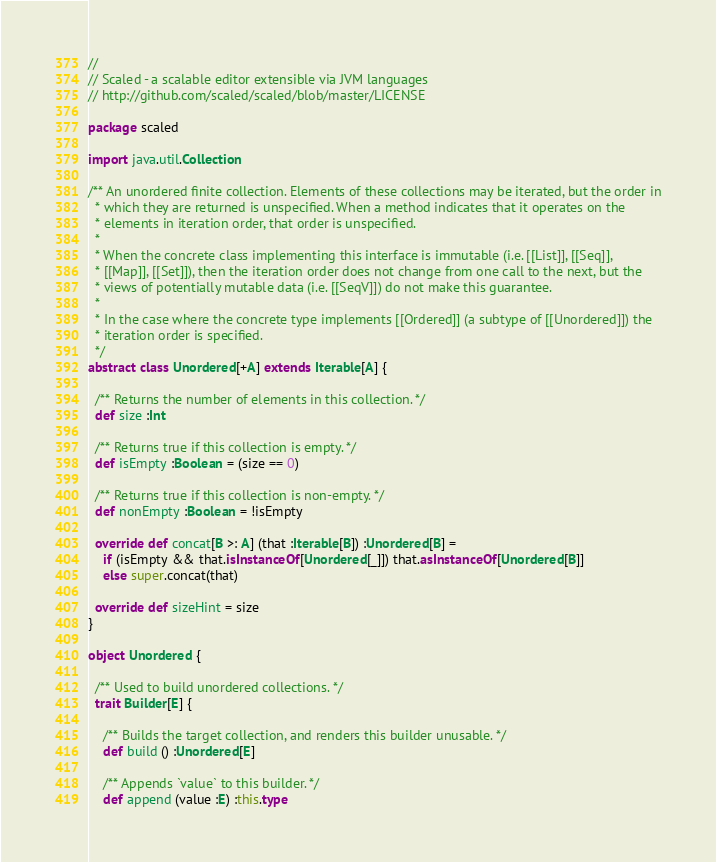<code> <loc_0><loc_0><loc_500><loc_500><_Scala_>//
// Scaled - a scalable editor extensible via JVM languages
// http://github.com/scaled/scaled/blob/master/LICENSE

package scaled

import java.util.Collection

/** An unordered finite collection. Elements of these collections may be iterated, but the order in
  * which they are returned is unspecified. When a method indicates that it operates on the
  * elements in iteration order, that order is unspecified.
  *
  * When the concrete class implementing this interface is immutable (i.e. [[List]], [[Seq]],
  * [[Map]], [[Set]]), then the iteration order does not change from one call to the next, but the
  * views of potentially mutable data (i.e. [[SeqV]]) do not make this guarantee.
  *
  * In the case where the concrete type implements [[Ordered]] (a subtype of [[Unordered]]) the
  * iteration order is specified.
  */
abstract class Unordered[+A] extends Iterable[A] {

  /** Returns the number of elements in this collection. */
  def size :Int

  /** Returns true if this collection is empty. */
  def isEmpty :Boolean = (size == 0)

  /** Returns true if this collection is non-empty. */
  def nonEmpty :Boolean = !isEmpty

  override def concat[B >: A] (that :Iterable[B]) :Unordered[B] =
    if (isEmpty && that.isInstanceOf[Unordered[_]]) that.asInstanceOf[Unordered[B]]
    else super.concat(that)

  override def sizeHint = size
}

object Unordered {

  /** Used to build unordered collections. */
  trait Builder[E] {

    /** Builds the target collection, and renders this builder unusable. */
    def build () :Unordered[E]

    /** Appends `value` to this builder. */
    def append (value :E) :this.type</code> 